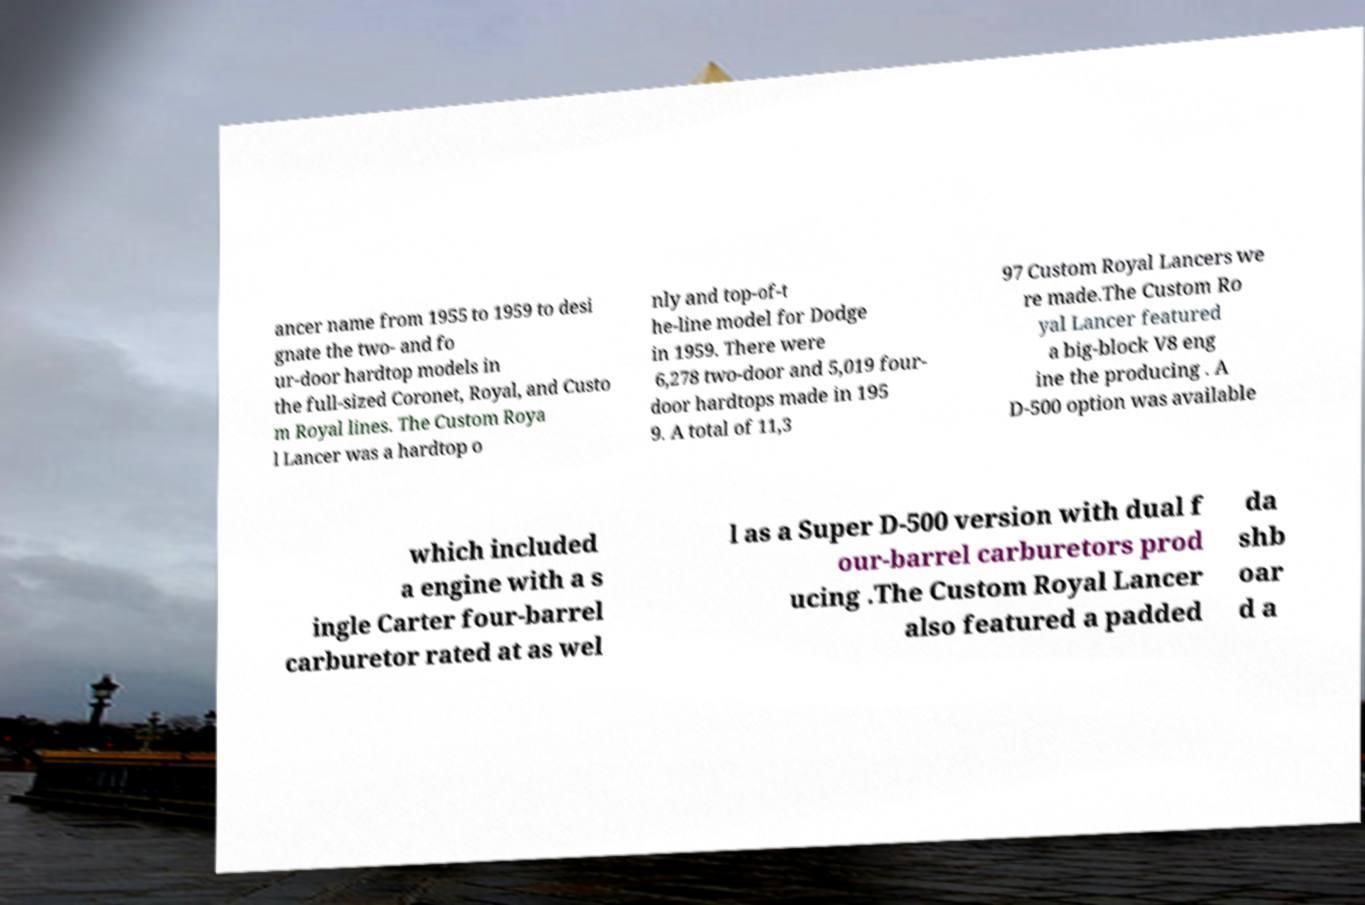Could you extract and type out the text from this image? ancer name from 1955 to 1959 to desi gnate the two- and fo ur-door hardtop models in the full-sized Coronet, Royal, and Custo m Royal lines. The Custom Roya l Lancer was a hardtop o nly and top-of-t he-line model for Dodge in 1959. There were 6,278 two-door and 5,019 four- door hardtops made in 195 9. A total of 11,3 97 Custom Royal Lancers we re made.The Custom Ro yal Lancer featured a big-block V8 eng ine the producing . A D-500 option was available which included a engine with a s ingle Carter four-barrel carburetor rated at as wel l as a Super D-500 version with dual f our-barrel carburetors prod ucing .The Custom Royal Lancer also featured a padded da shb oar d a 